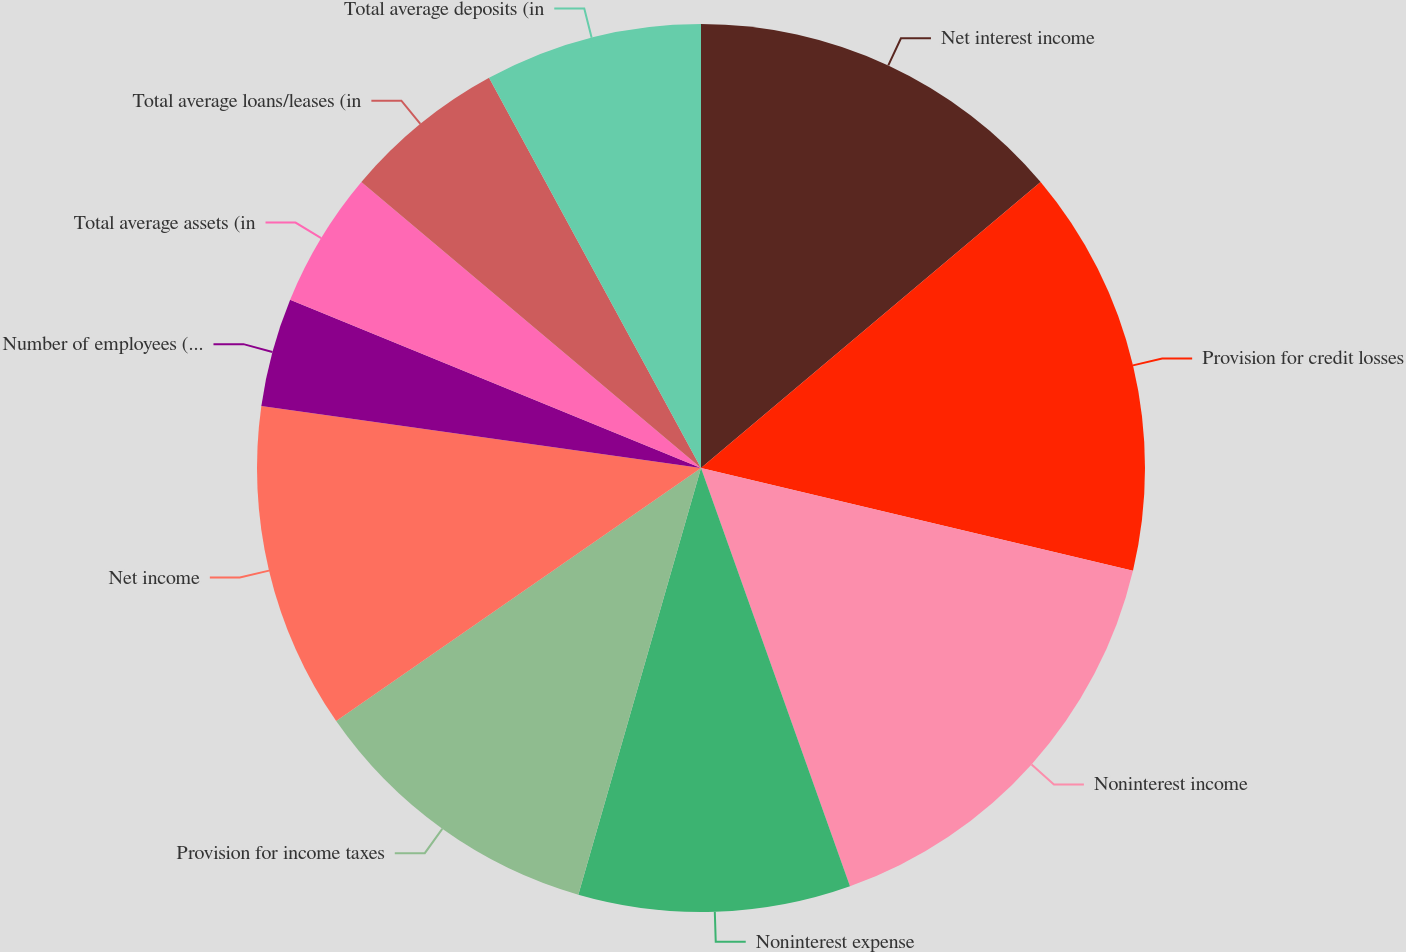Convert chart. <chart><loc_0><loc_0><loc_500><loc_500><pie_chart><fcel>Net interest income<fcel>Provision for credit losses<fcel>Noninterest income<fcel>Noninterest expense<fcel>Provision for income taxes<fcel>Net income<fcel>Number of employees (full-time<fcel>Total average assets (in<fcel>Total average loans/leases (in<fcel>Total average deposits (in<nl><fcel>13.86%<fcel>14.85%<fcel>15.84%<fcel>9.9%<fcel>10.89%<fcel>11.88%<fcel>3.96%<fcel>4.95%<fcel>5.94%<fcel>7.92%<nl></chart> 